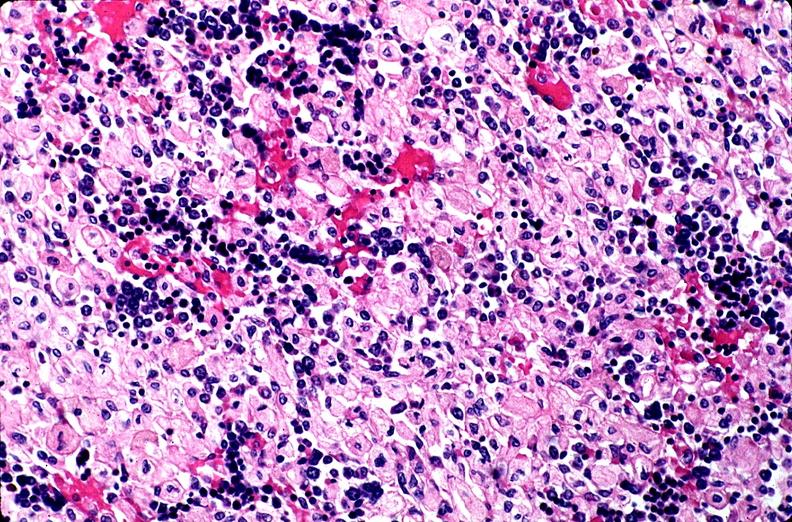s hematologic present?
Answer the question using a single word or phrase. Yes 